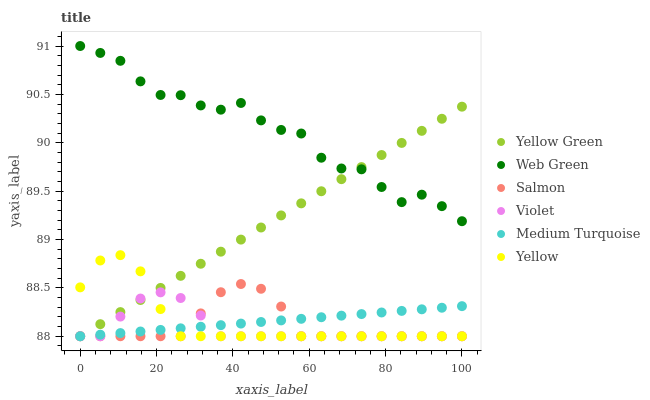Does Violet have the minimum area under the curve?
Answer yes or no. Yes. Does Web Green have the maximum area under the curve?
Answer yes or no. Yes. Does Salmon have the minimum area under the curve?
Answer yes or no. No. Does Salmon have the maximum area under the curve?
Answer yes or no. No. Is Medium Turquoise the smoothest?
Answer yes or no. Yes. Is Web Green the roughest?
Answer yes or no. Yes. Is Salmon the smoothest?
Answer yes or no. No. Is Salmon the roughest?
Answer yes or no. No. Does Yellow Green have the lowest value?
Answer yes or no. Yes. Does Web Green have the lowest value?
Answer yes or no. No. Does Web Green have the highest value?
Answer yes or no. Yes. Does Salmon have the highest value?
Answer yes or no. No. Is Salmon less than Web Green?
Answer yes or no. Yes. Is Web Green greater than Salmon?
Answer yes or no. Yes. Does Medium Turquoise intersect Violet?
Answer yes or no. Yes. Is Medium Turquoise less than Violet?
Answer yes or no. No. Is Medium Turquoise greater than Violet?
Answer yes or no. No. Does Salmon intersect Web Green?
Answer yes or no. No. 